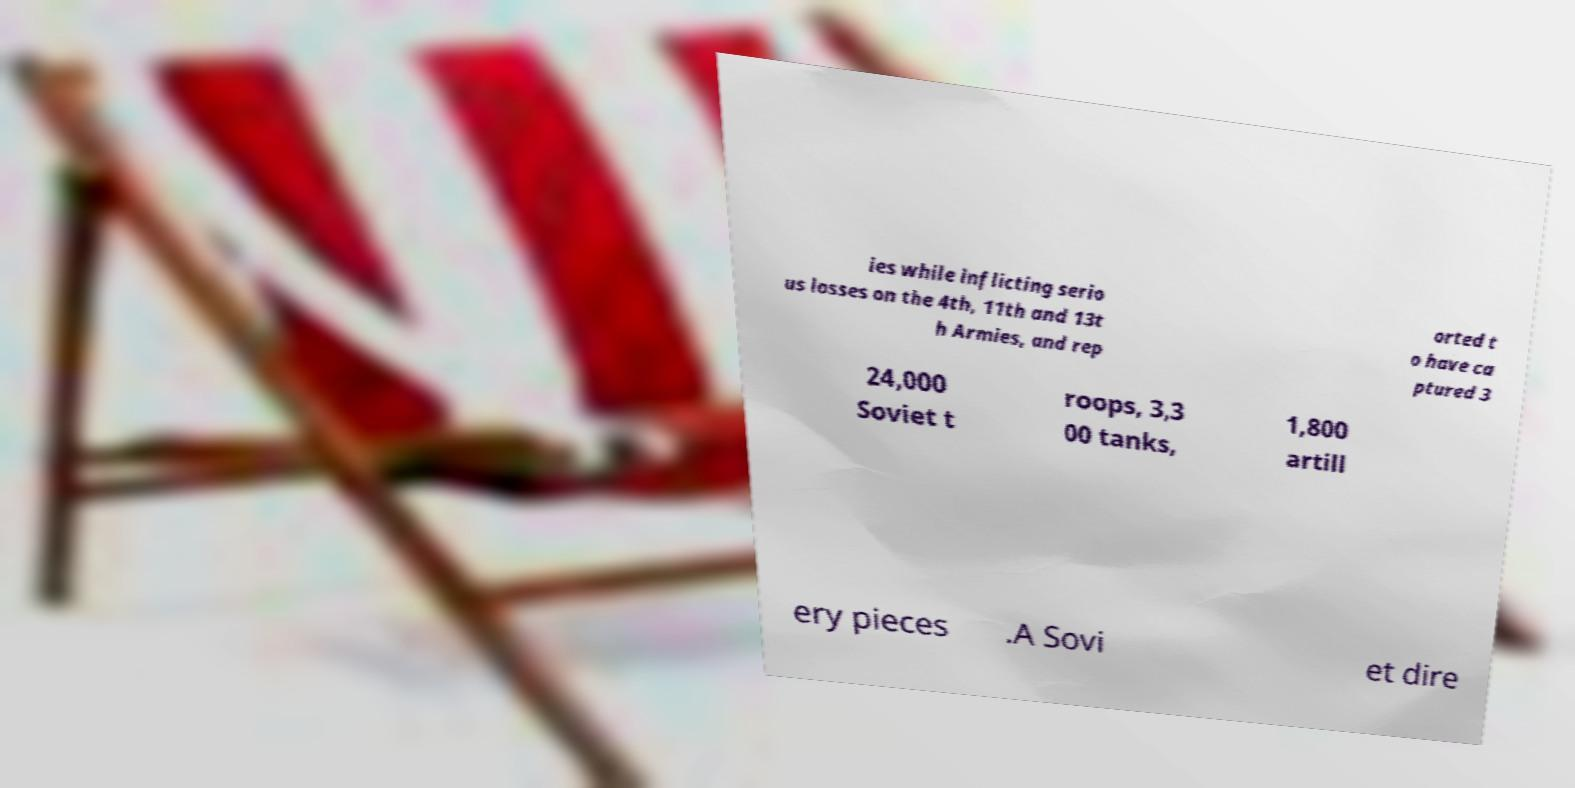There's text embedded in this image that I need extracted. Can you transcribe it verbatim? ies while inflicting serio us losses on the 4th, 11th and 13t h Armies, and rep orted t o have ca ptured 3 24,000 Soviet t roops, 3,3 00 tanks, 1,800 artill ery pieces .A Sovi et dire 